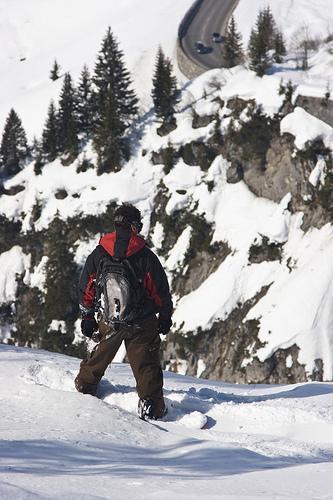What is near the trees?
From the following four choices, select the correct answer to address the question.
Options: Wolves, hyenas, beavers, snow. Snow. 